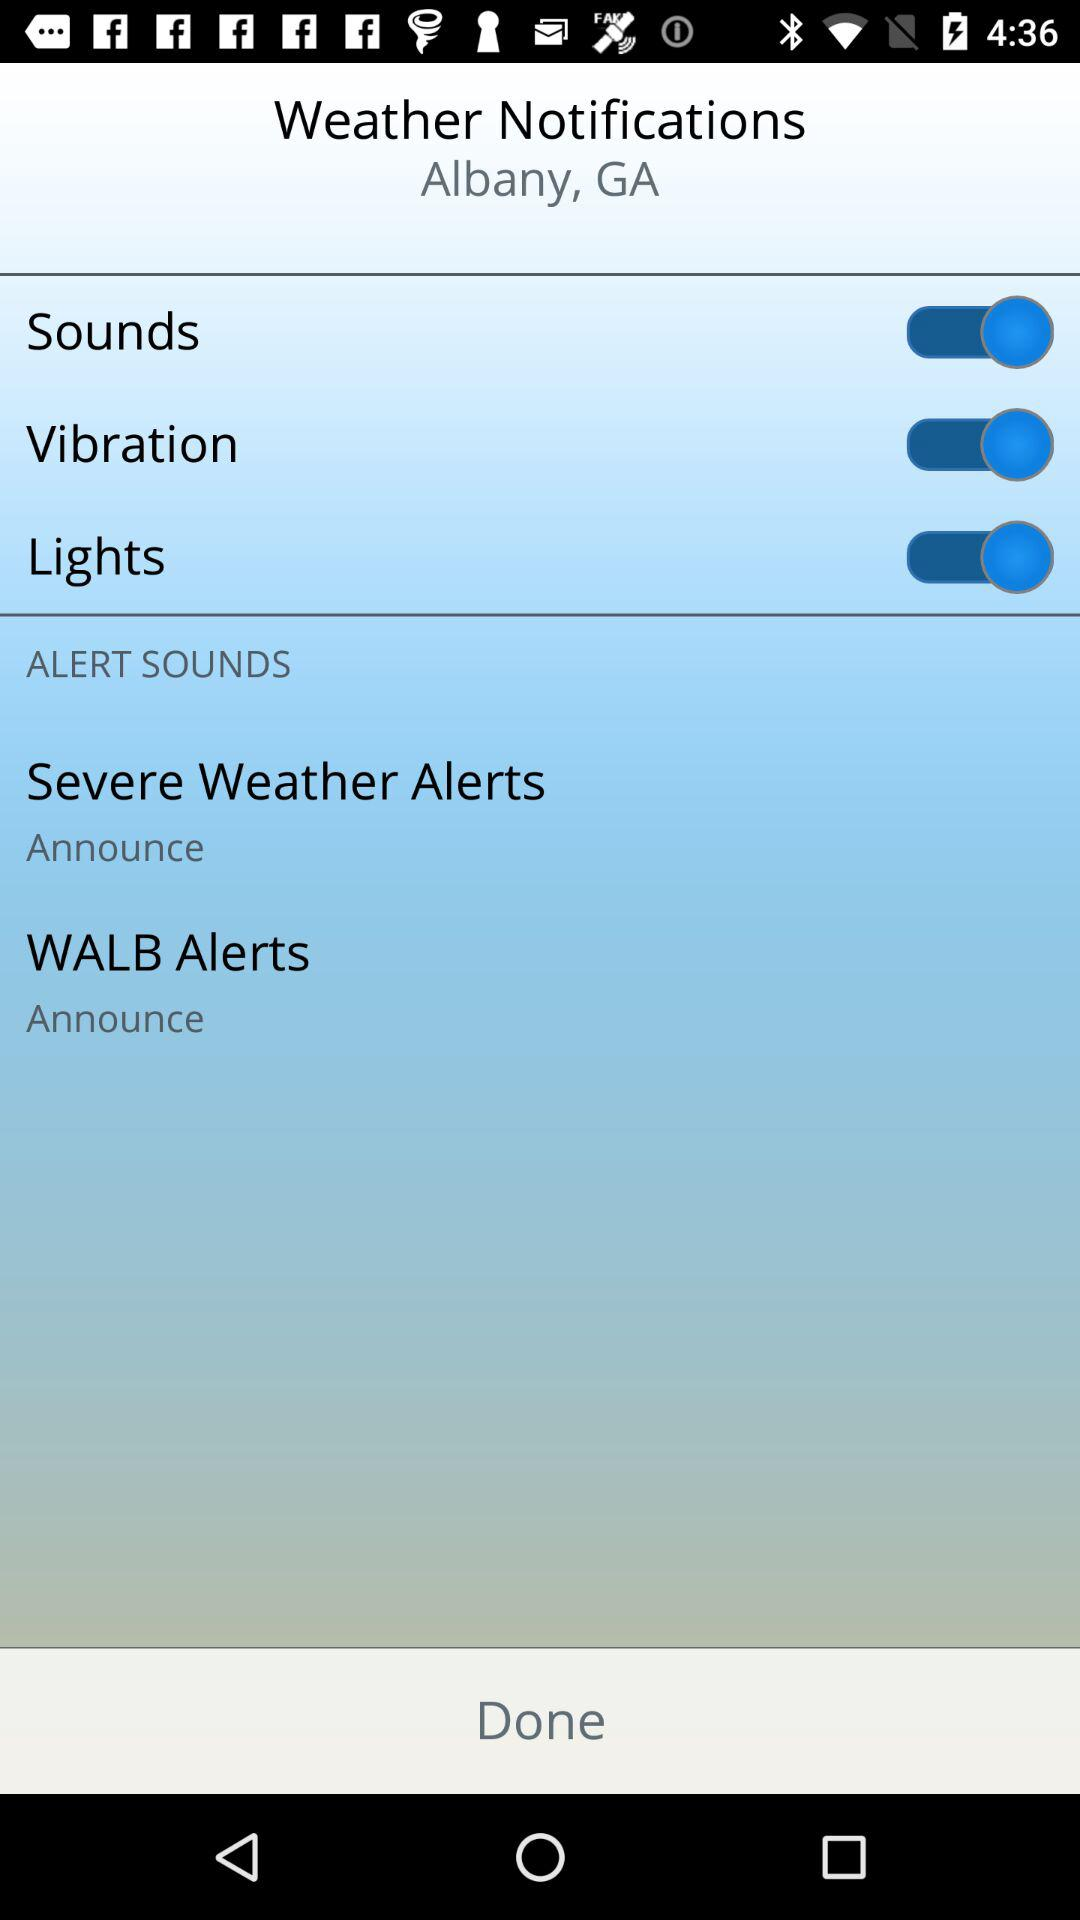What is the status of "Sounds"? The status is "on". 